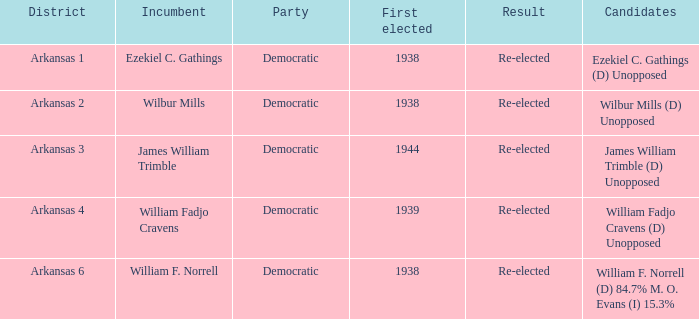How many incumbents had a district of Arkansas 3? 1.0. 